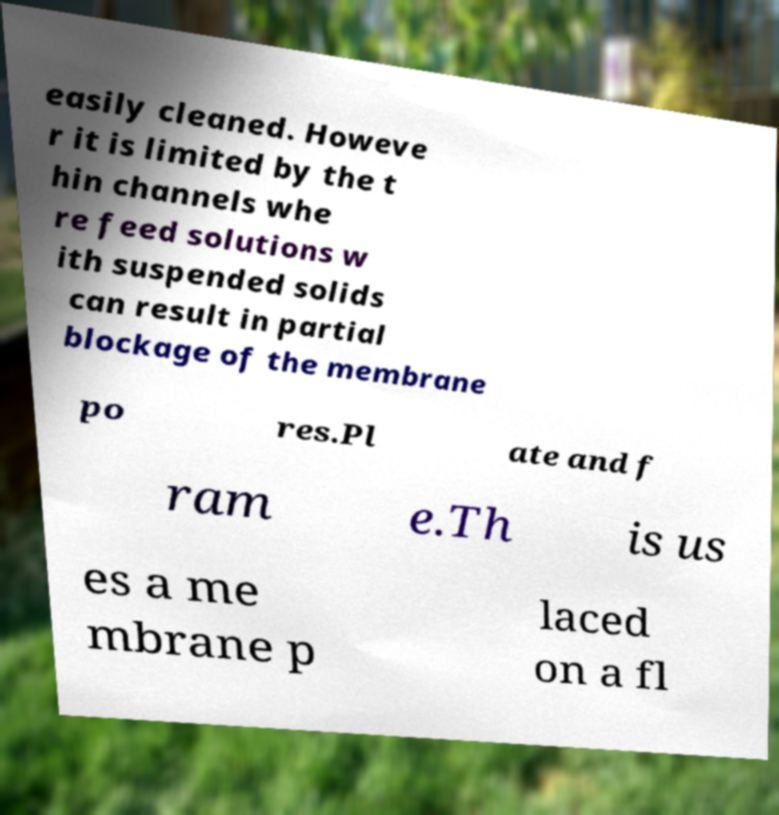For documentation purposes, I need the text within this image transcribed. Could you provide that? easily cleaned. Howeve r it is limited by the t hin channels whe re feed solutions w ith suspended solids can result in partial blockage of the membrane po res.Pl ate and f ram e.Th is us es a me mbrane p laced on a fl 